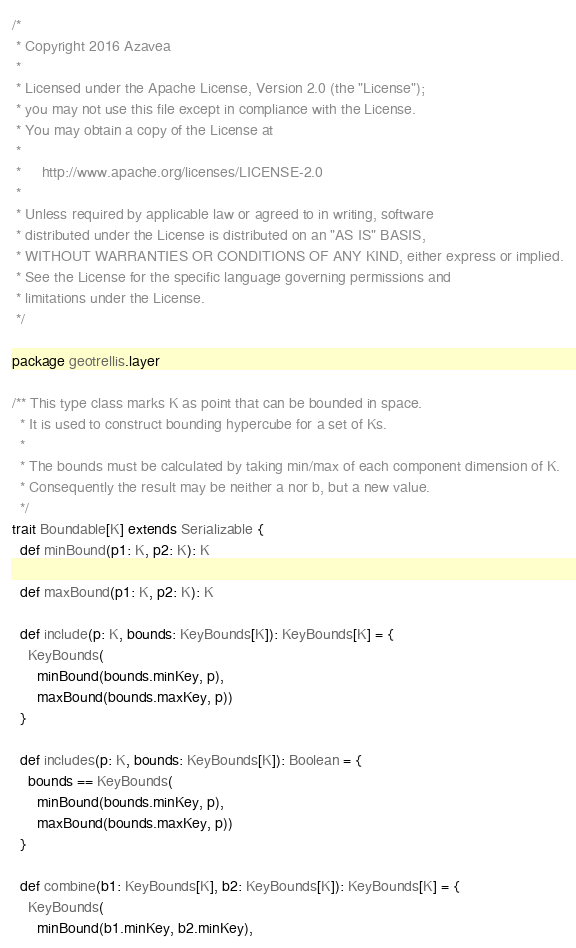<code> <loc_0><loc_0><loc_500><loc_500><_Scala_>/*
 * Copyright 2016 Azavea
 *
 * Licensed under the Apache License, Version 2.0 (the "License");
 * you may not use this file except in compliance with the License.
 * You may obtain a copy of the License at
 *
 *     http://www.apache.org/licenses/LICENSE-2.0
 *
 * Unless required by applicable law or agreed to in writing, software
 * distributed under the License is distributed on an "AS IS" BASIS,
 * WITHOUT WARRANTIES OR CONDITIONS OF ANY KIND, either express or implied.
 * See the License for the specific language governing permissions and
 * limitations under the License.
 */

package geotrellis.layer

/** This type class marks K as point that can be bounded in space.
  * It is used to construct bounding hypercube for a set of Ks.
  *
  * The bounds must be calculated by taking min/max of each component dimension of K.
  * Consequently the result may be neither a nor b, but a new value.
  */
trait Boundable[K] extends Serializable {
  def minBound(p1: K, p2: K): K

  def maxBound(p1: K, p2: K): K

  def include(p: K, bounds: KeyBounds[K]): KeyBounds[K] = {
    KeyBounds(
      minBound(bounds.minKey, p),
      maxBound(bounds.maxKey, p))
  }

  def includes(p: K, bounds: KeyBounds[K]): Boolean = {
    bounds == KeyBounds(
      minBound(bounds.minKey, p),
      maxBound(bounds.maxKey, p))
  }

  def combine(b1: KeyBounds[K], b2: KeyBounds[K]): KeyBounds[K] = {
    KeyBounds(
      minBound(b1.minKey, b2.minKey),</code> 